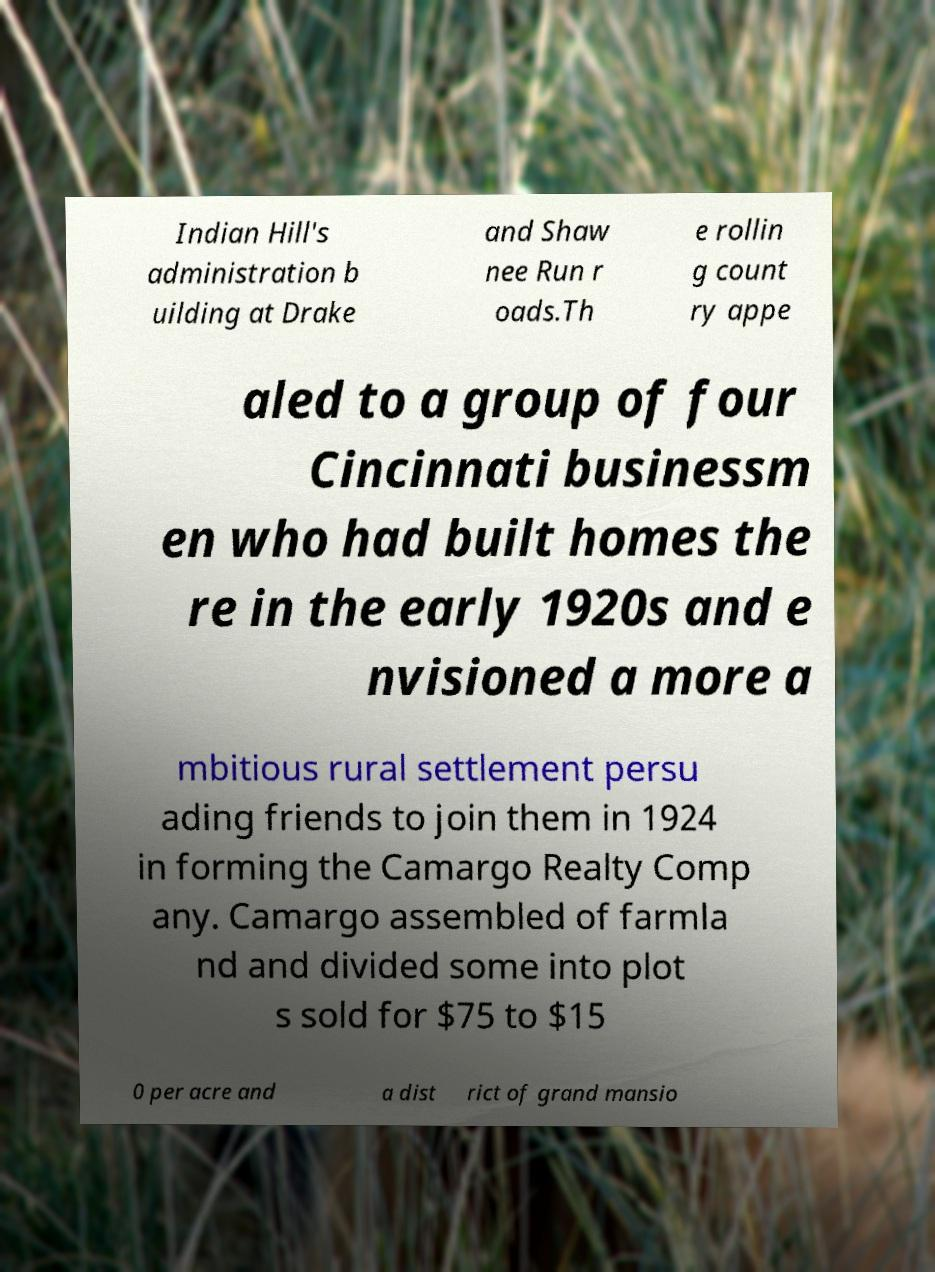I need the written content from this picture converted into text. Can you do that? Indian Hill's administration b uilding at Drake and Shaw nee Run r oads.Th e rollin g count ry appe aled to a group of four Cincinnati businessm en who had built homes the re in the early 1920s and e nvisioned a more a mbitious rural settlement persu ading friends to join them in 1924 in forming the Camargo Realty Comp any. Camargo assembled of farmla nd and divided some into plot s sold for $75 to $15 0 per acre and a dist rict of grand mansio 